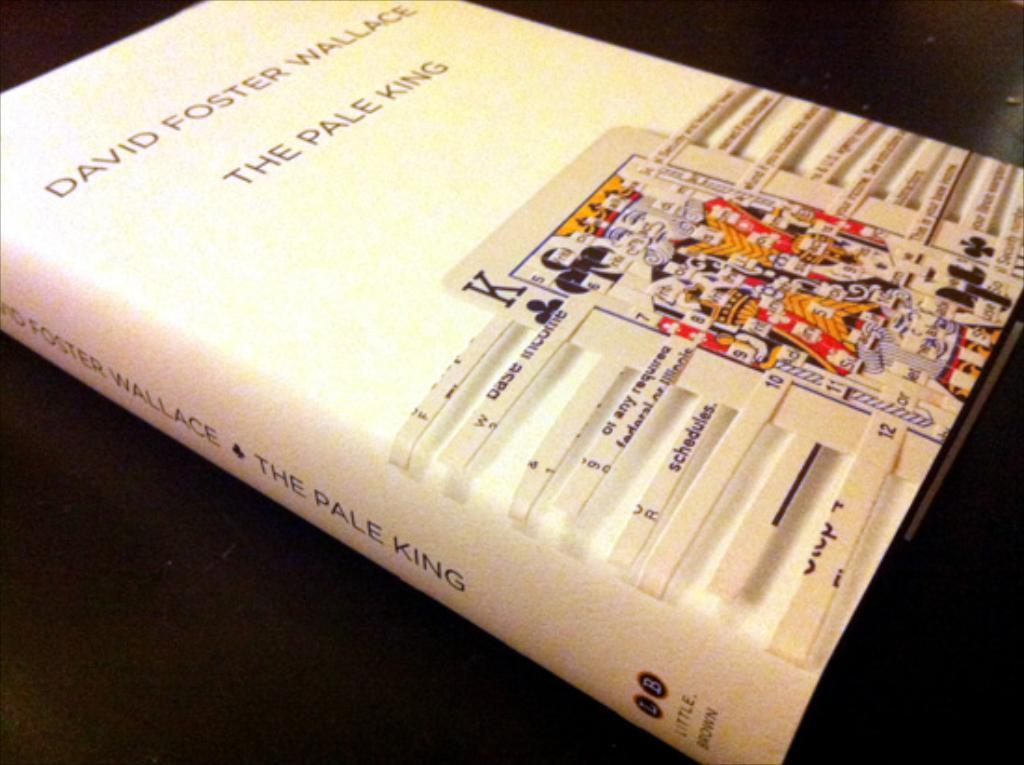Provide a one-sentence caption for the provided image. A playing card image decorates the cover of David Foster Wallace's "Pale King" book. 